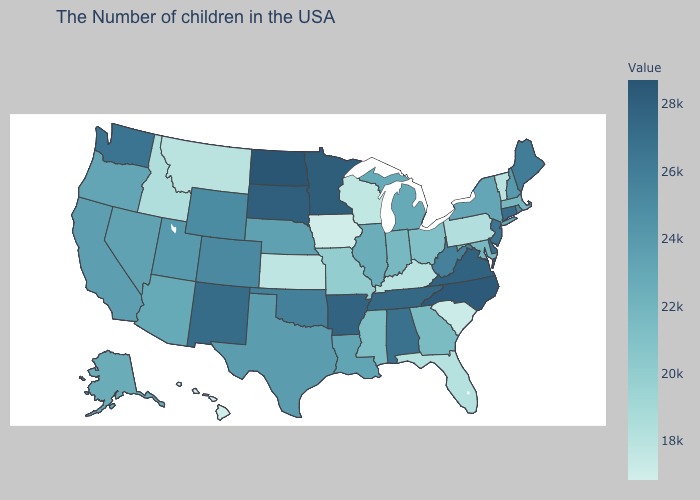Does the map have missing data?
Write a very short answer. No. Which states have the lowest value in the USA?
Give a very brief answer. Hawaii. Is the legend a continuous bar?
Answer briefly. Yes. Among the states that border Maine , which have the lowest value?
Be succinct. New Hampshire. 